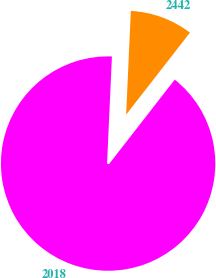Convert chart to OTSL. <chart><loc_0><loc_0><loc_500><loc_500><pie_chart><fcel>2018<fcel>2442<nl><fcel>90.2%<fcel>9.8%<nl></chart> 